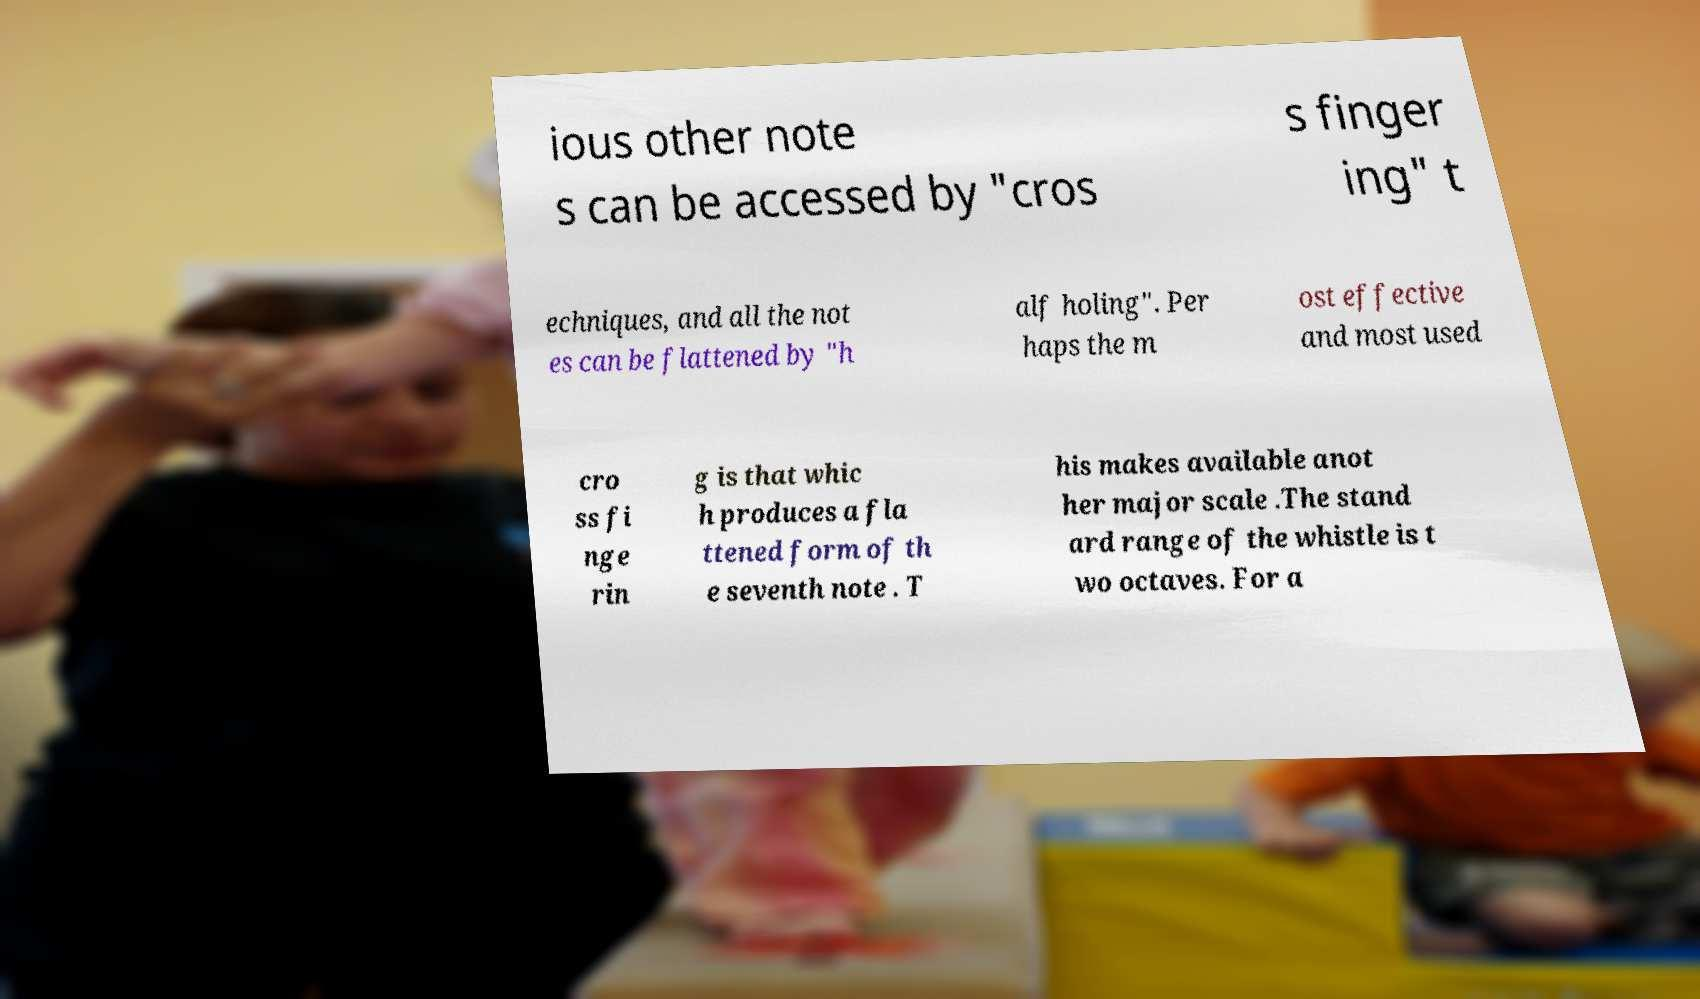Can you read and provide the text displayed in the image?This photo seems to have some interesting text. Can you extract and type it out for me? ious other note s can be accessed by "cros s finger ing" t echniques, and all the not es can be flattened by "h alf holing". Per haps the m ost effective and most used cro ss fi nge rin g is that whic h produces a fla ttened form of th e seventh note . T his makes available anot her major scale .The stand ard range of the whistle is t wo octaves. For a 